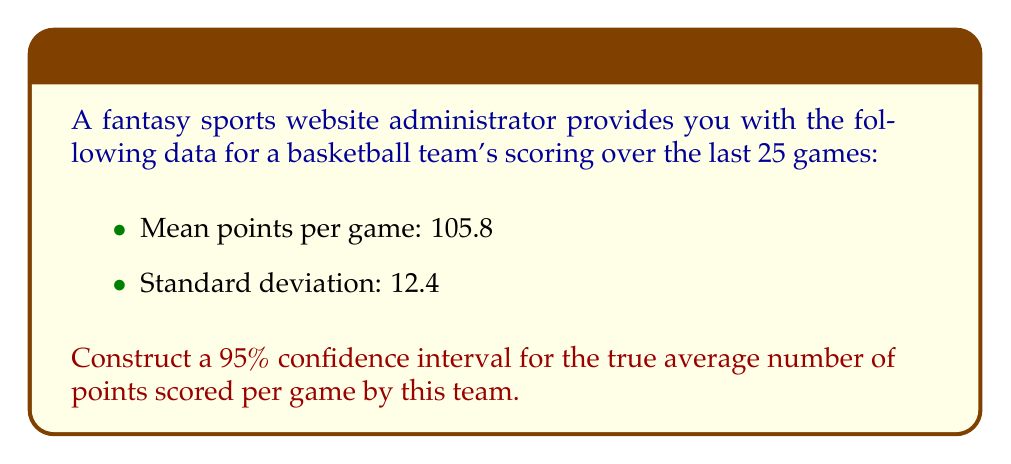Teach me how to tackle this problem. To construct a 95% confidence interval, we'll follow these steps:

1) The formula for a confidence interval is:

   $$\bar{x} \pm t_{\alpha/2} \cdot \frac{s}{\sqrt{n}}$$

   Where:
   $\bar{x}$ is the sample mean
   $t_{\alpha/2}$ is the t-value for the desired confidence level
   $s$ is the sample standard deviation
   $n$ is the sample size

2) We know:
   $\bar{x} = 105.8$
   $s = 12.4$
   $n = 25$
   Confidence level = 95%, so $\alpha = 0.05$

3) For a 95% confidence interval with 24 degrees of freedom (n-1), the t-value is approximately 2.064. (You would typically look this up in a t-table)

4) Now, let's substitute these values into our formula:

   $$105.8 \pm 2.064 \cdot \frac{12.4}{\sqrt{25}}$$

5) Simplify:
   $$105.8 \pm 2.064 \cdot \frac{12.4}{5}$$
   $$105.8 \pm 2.064 \cdot 2.48$$
   $$105.8 \pm 5.12$$

6) Therefore, our confidence interval is:
   $$(105.8 - 5.12, 105.8 + 5.12)$$
   $$(100.68, 110.92)$$
Answer: (100.68, 110.92) 